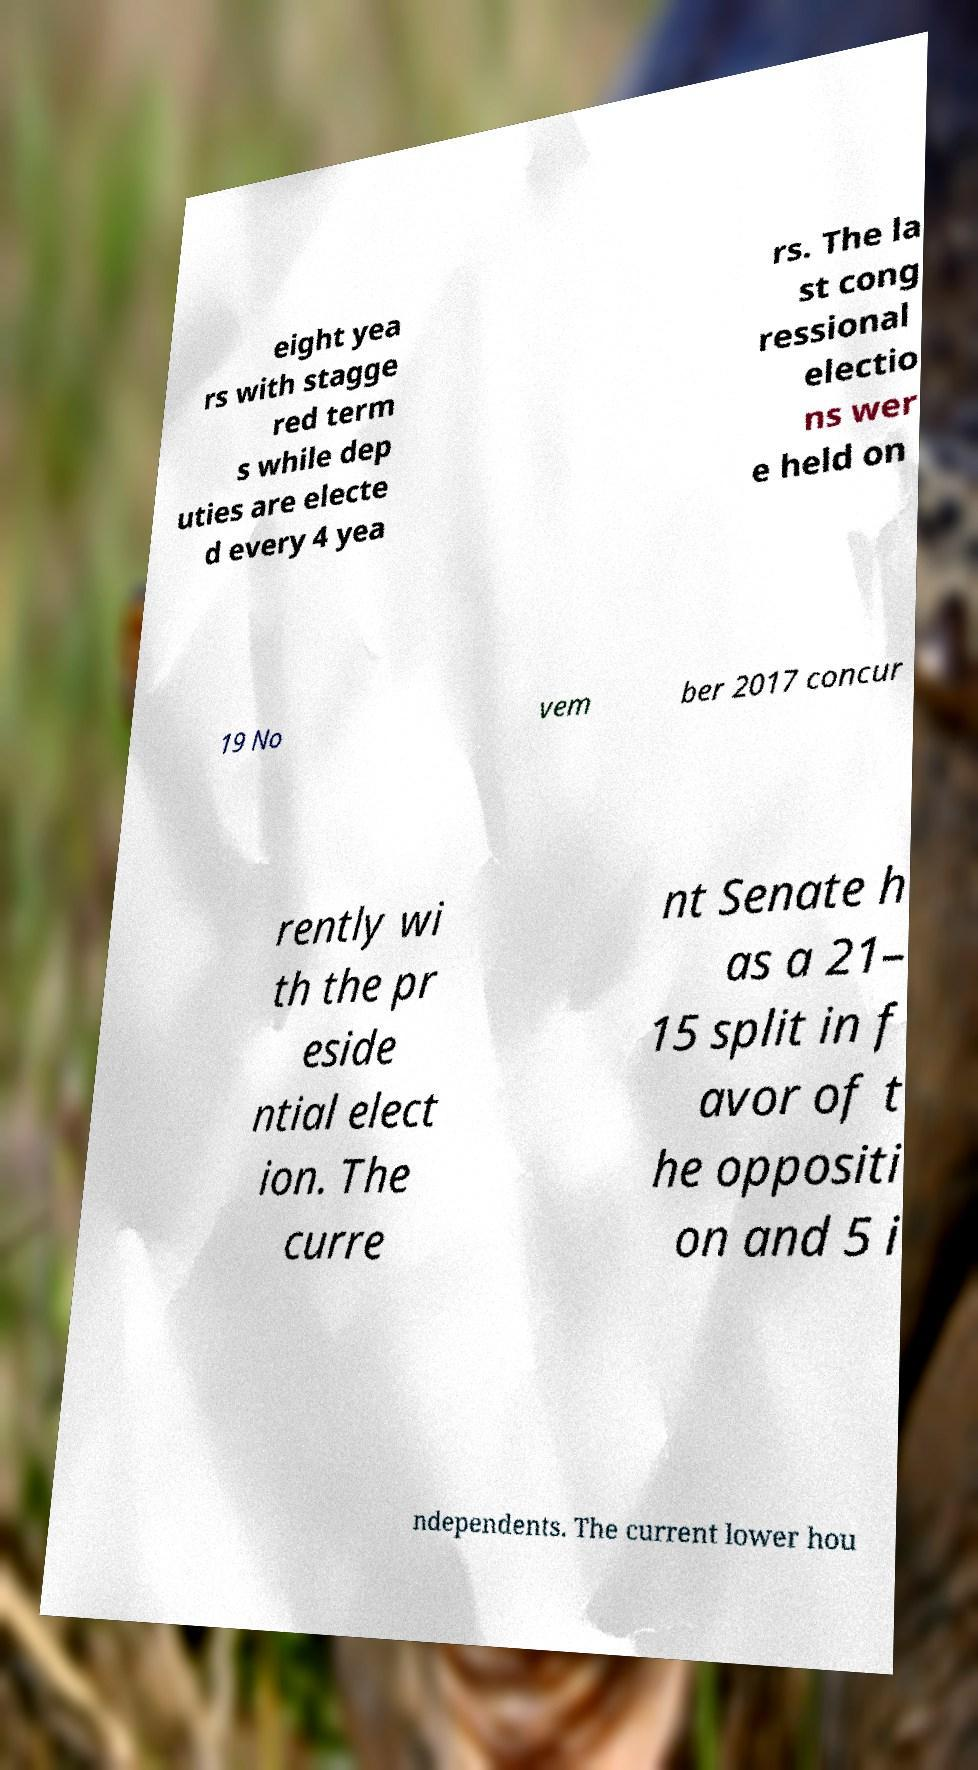Could you extract and type out the text from this image? eight yea rs with stagge red term s while dep uties are electe d every 4 yea rs. The la st cong ressional electio ns wer e held on 19 No vem ber 2017 concur rently wi th the pr eside ntial elect ion. The curre nt Senate h as a 21– 15 split in f avor of t he oppositi on and 5 i ndependents. The current lower hou 